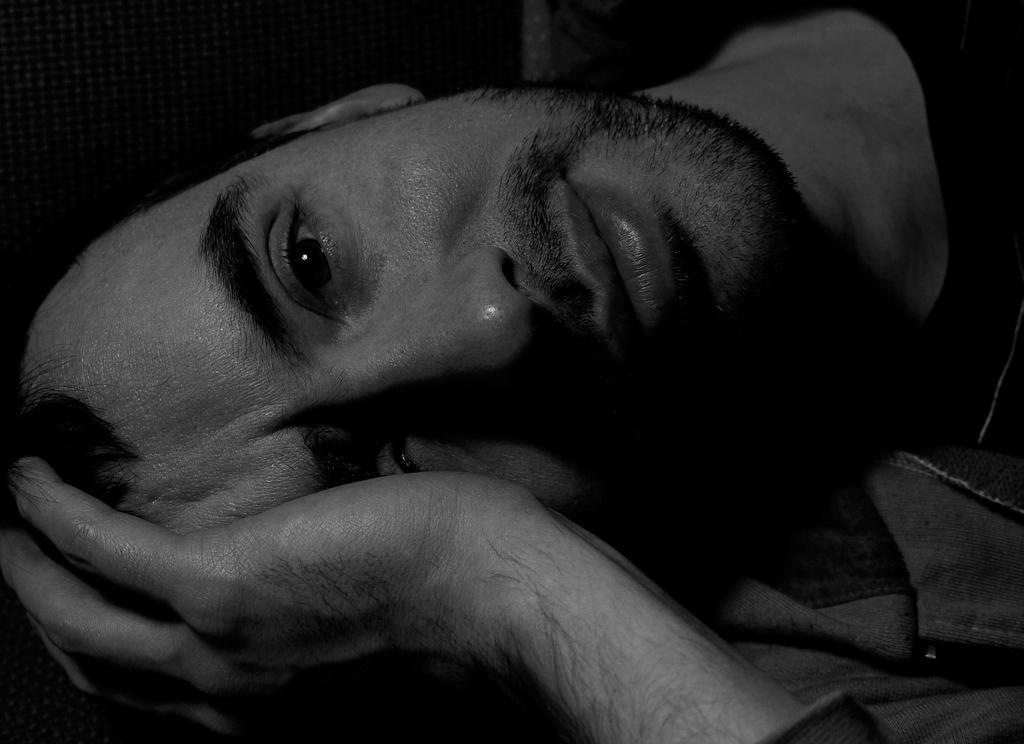Could you give a brief overview of what you see in this image? In this picture we can observe a person laying. He is wearing a hoodie. This is a black and white image. 